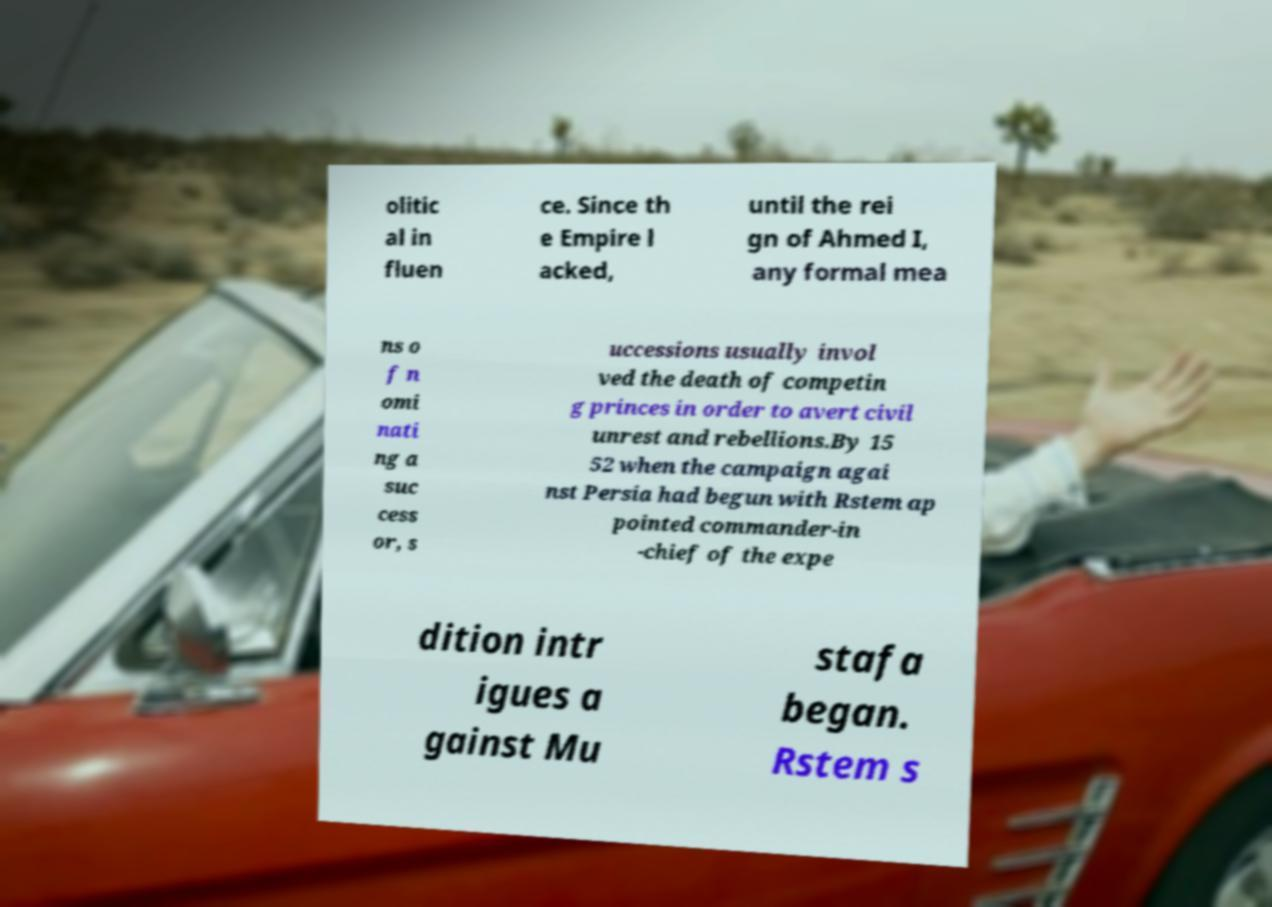Can you read and provide the text displayed in the image?This photo seems to have some interesting text. Can you extract and type it out for me? olitic al in fluen ce. Since th e Empire l acked, until the rei gn of Ahmed I, any formal mea ns o f n omi nati ng a suc cess or, s uccessions usually invol ved the death of competin g princes in order to avert civil unrest and rebellions.By 15 52 when the campaign agai nst Persia had begun with Rstem ap pointed commander-in -chief of the expe dition intr igues a gainst Mu stafa began. Rstem s 